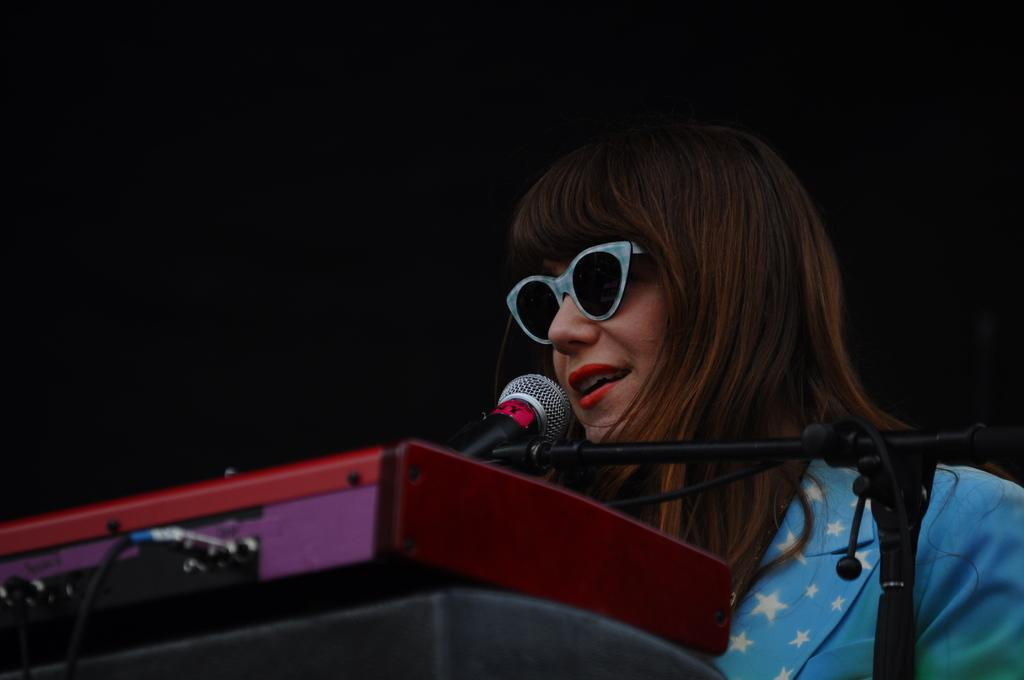What is the person in the image doing? The person is standing at a mic in the image. What musical instrument can be seen in the image? There is a keyboard visible at the bottom of the image. What type of prison is depicted in the image? There is no prison present in the image; it features a person standing at a mic and a keyboard. What kind of test is being conducted in the image? There is no test being conducted in the image; it shows a person at a mic and a keyboard, which suggests a musical performance or practice. 